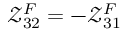Convert formula to latex. <formula><loc_0><loc_0><loc_500><loc_500>\mathcal { Z } _ { 3 2 } ^ { F } = - \mathcal { Z } _ { 3 1 } ^ { F }</formula> 